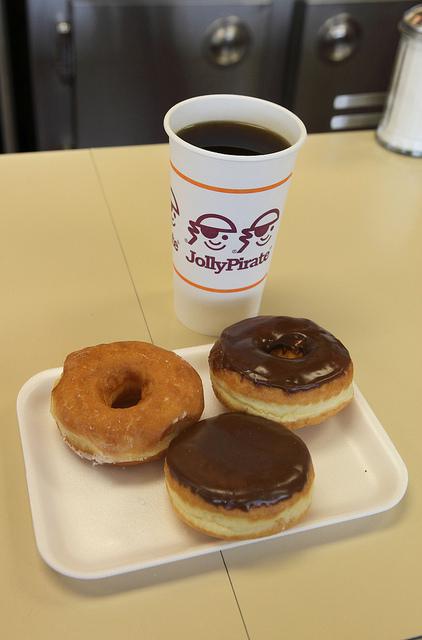What kind of food is this?
Short answer required. Donuts. How many doughnut do you see?
Keep it brief. 3. Is this a bagel?
Write a very short answer. No. What type of drink is in the cup?
Be succinct. Coffee. How many desserts are on each plate?
Give a very brief answer. 3. 